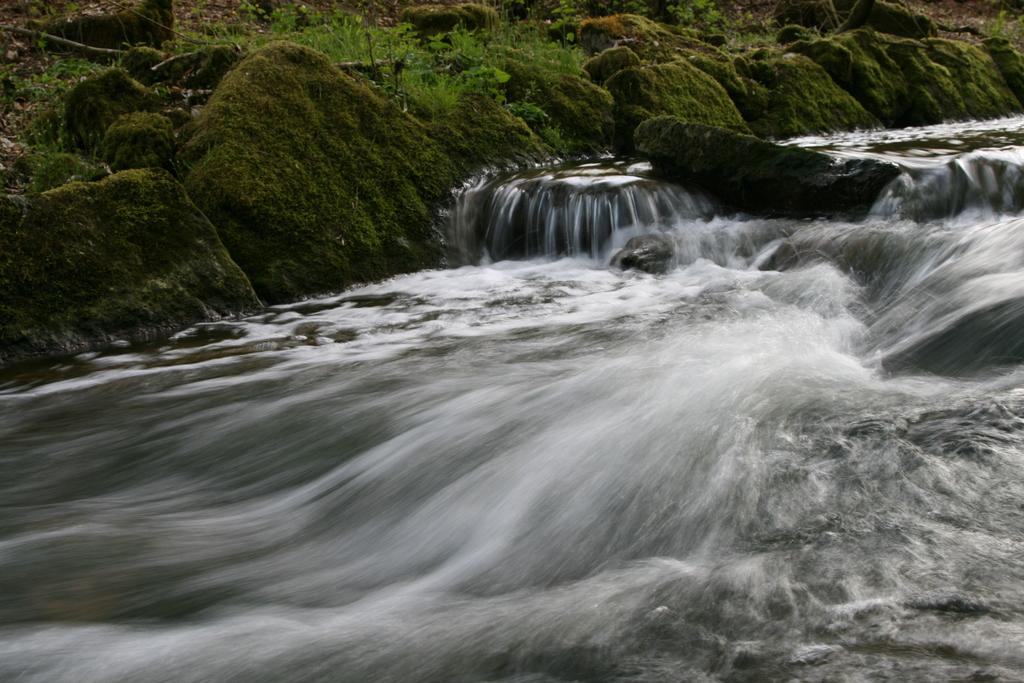What is the primary element visible in the image? There is water in the image. What other objects or features can be seen in the image? There are rocks and plants visible in the image. Where are the plants located in relation to the other elements in the image? The plants are visible at the back of the image. What type of basketball court can be seen in the image? There is no basketball court present in the image; it features water, rocks, and plants. 